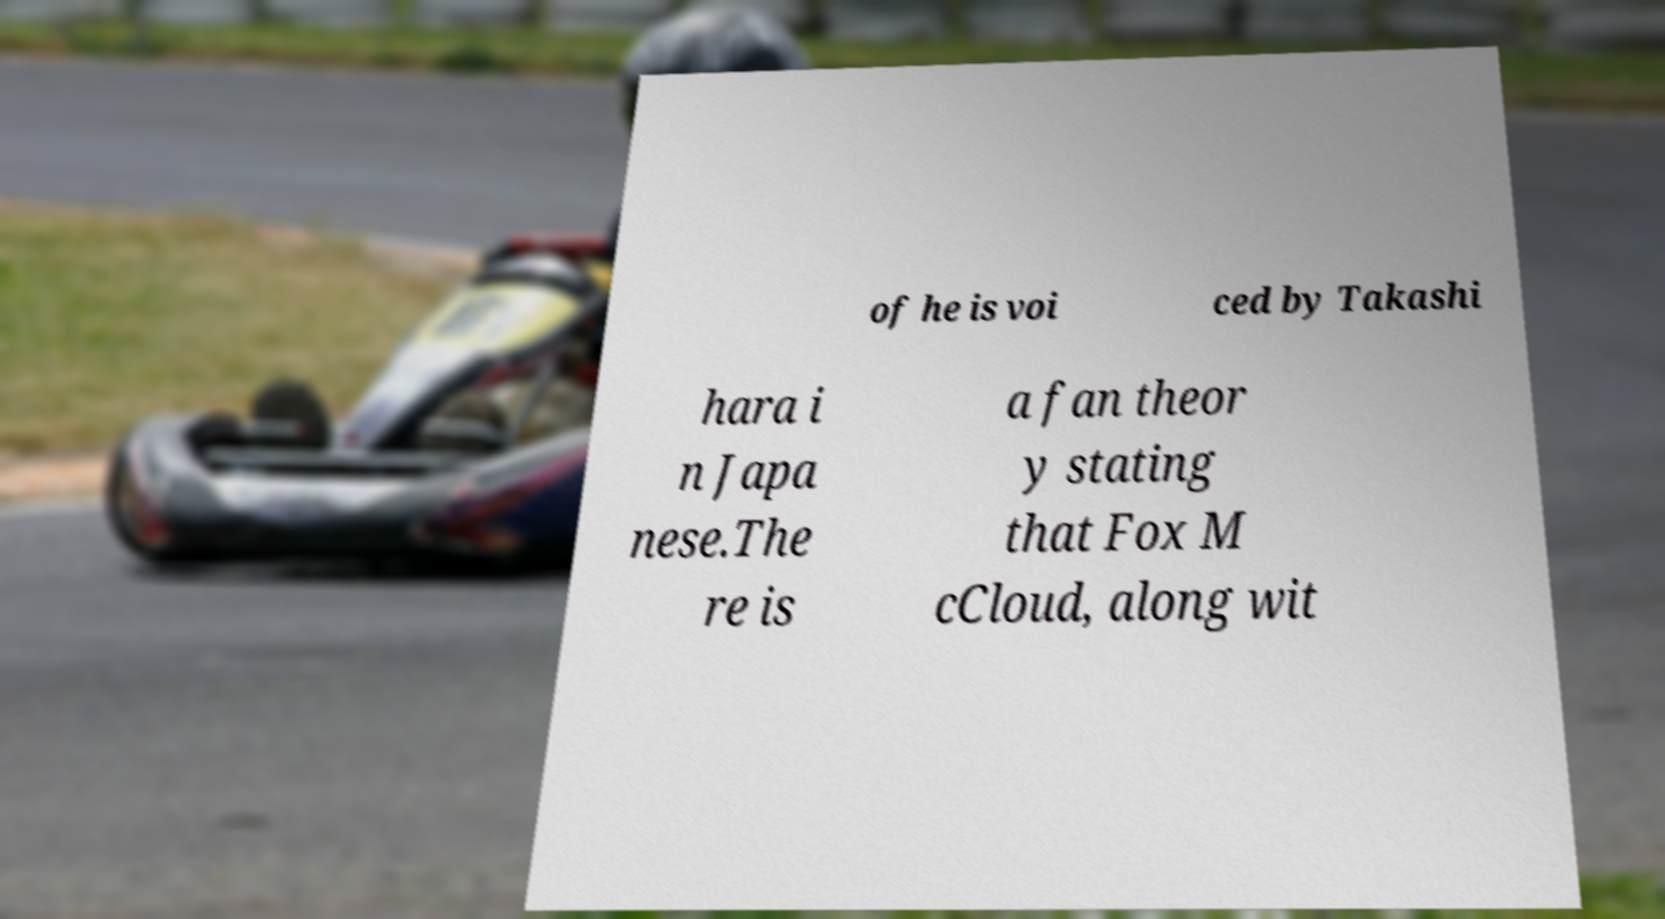Please read and relay the text visible in this image. What does it say? of he is voi ced by Takashi hara i n Japa nese.The re is a fan theor y stating that Fox M cCloud, along wit 